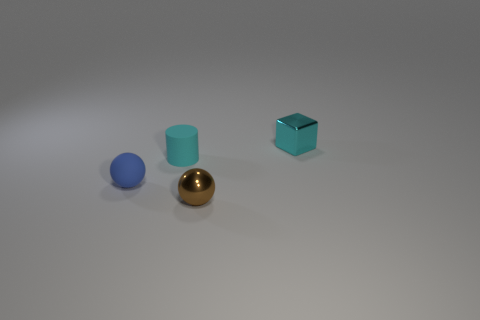What shape is the rubber object that is behind the tiny blue rubber thing behind the shiny object left of the cyan metal cube? cylinder 